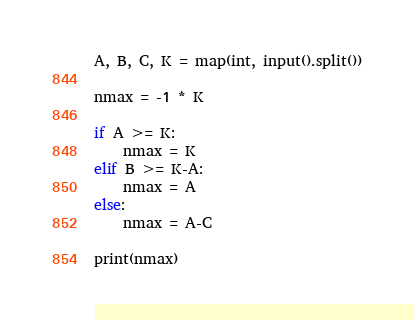Convert code to text. <code><loc_0><loc_0><loc_500><loc_500><_Python_>A, B, C, K = map(int, input().split())

nmax = -1 * K 

if A >= K:
    nmax = K
elif B >= K-A:
    nmax = A
else:
    nmax = A-C
            
print(nmax)</code> 